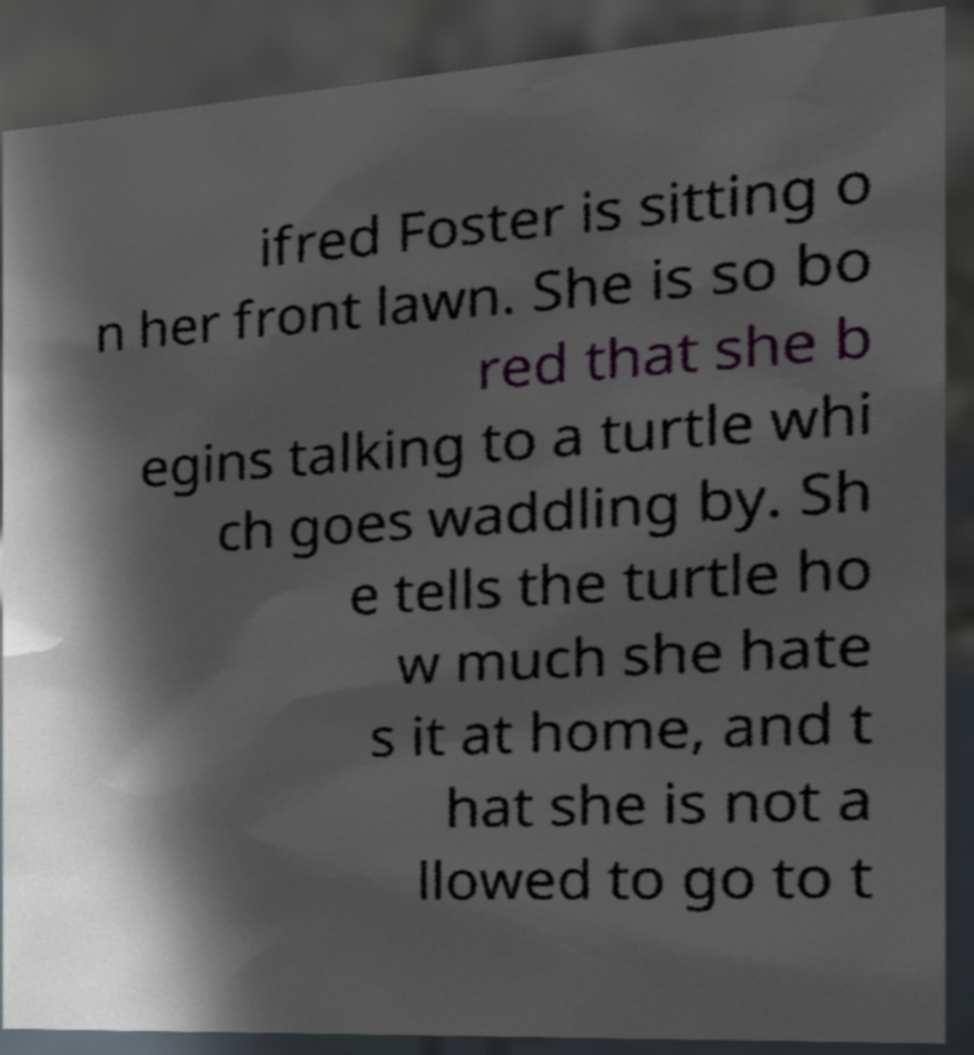Can you read and provide the text displayed in the image?This photo seems to have some interesting text. Can you extract and type it out for me? ifred Foster is sitting o n her front lawn. She is so bo red that she b egins talking to a turtle whi ch goes waddling by. Sh e tells the turtle ho w much she hate s it at home, and t hat she is not a llowed to go to t 